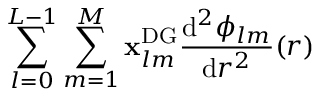Convert formula to latex. <formula><loc_0><loc_0><loc_500><loc_500>\sum _ { l = 0 } ^ { L - 1 } \sum _ { m = 1 } ^ { M } x _ { l m } ^ { D G } \frac { d ^ { 2 } \phi _ { l m } } { d r ^ { 2 } } ( r )</formula> 